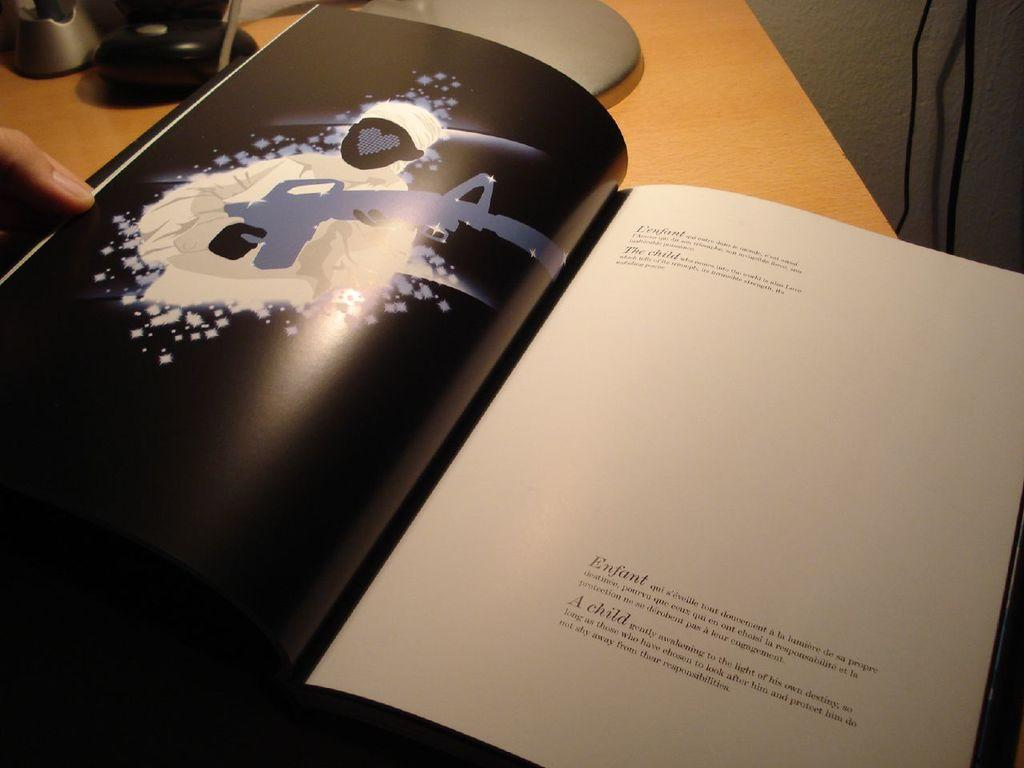What object can be seen in the image? There is a book in the image. Can you describe any other details about the image? Human fingers are visible on the left side of the image. What type of bird can be seen on the page of the book in the image? There is no bird present on the page of the book in the image. Can you describe the ear of the person holding the book in the image? There is no ear visible in the image; only human fingers are present on the left side. 